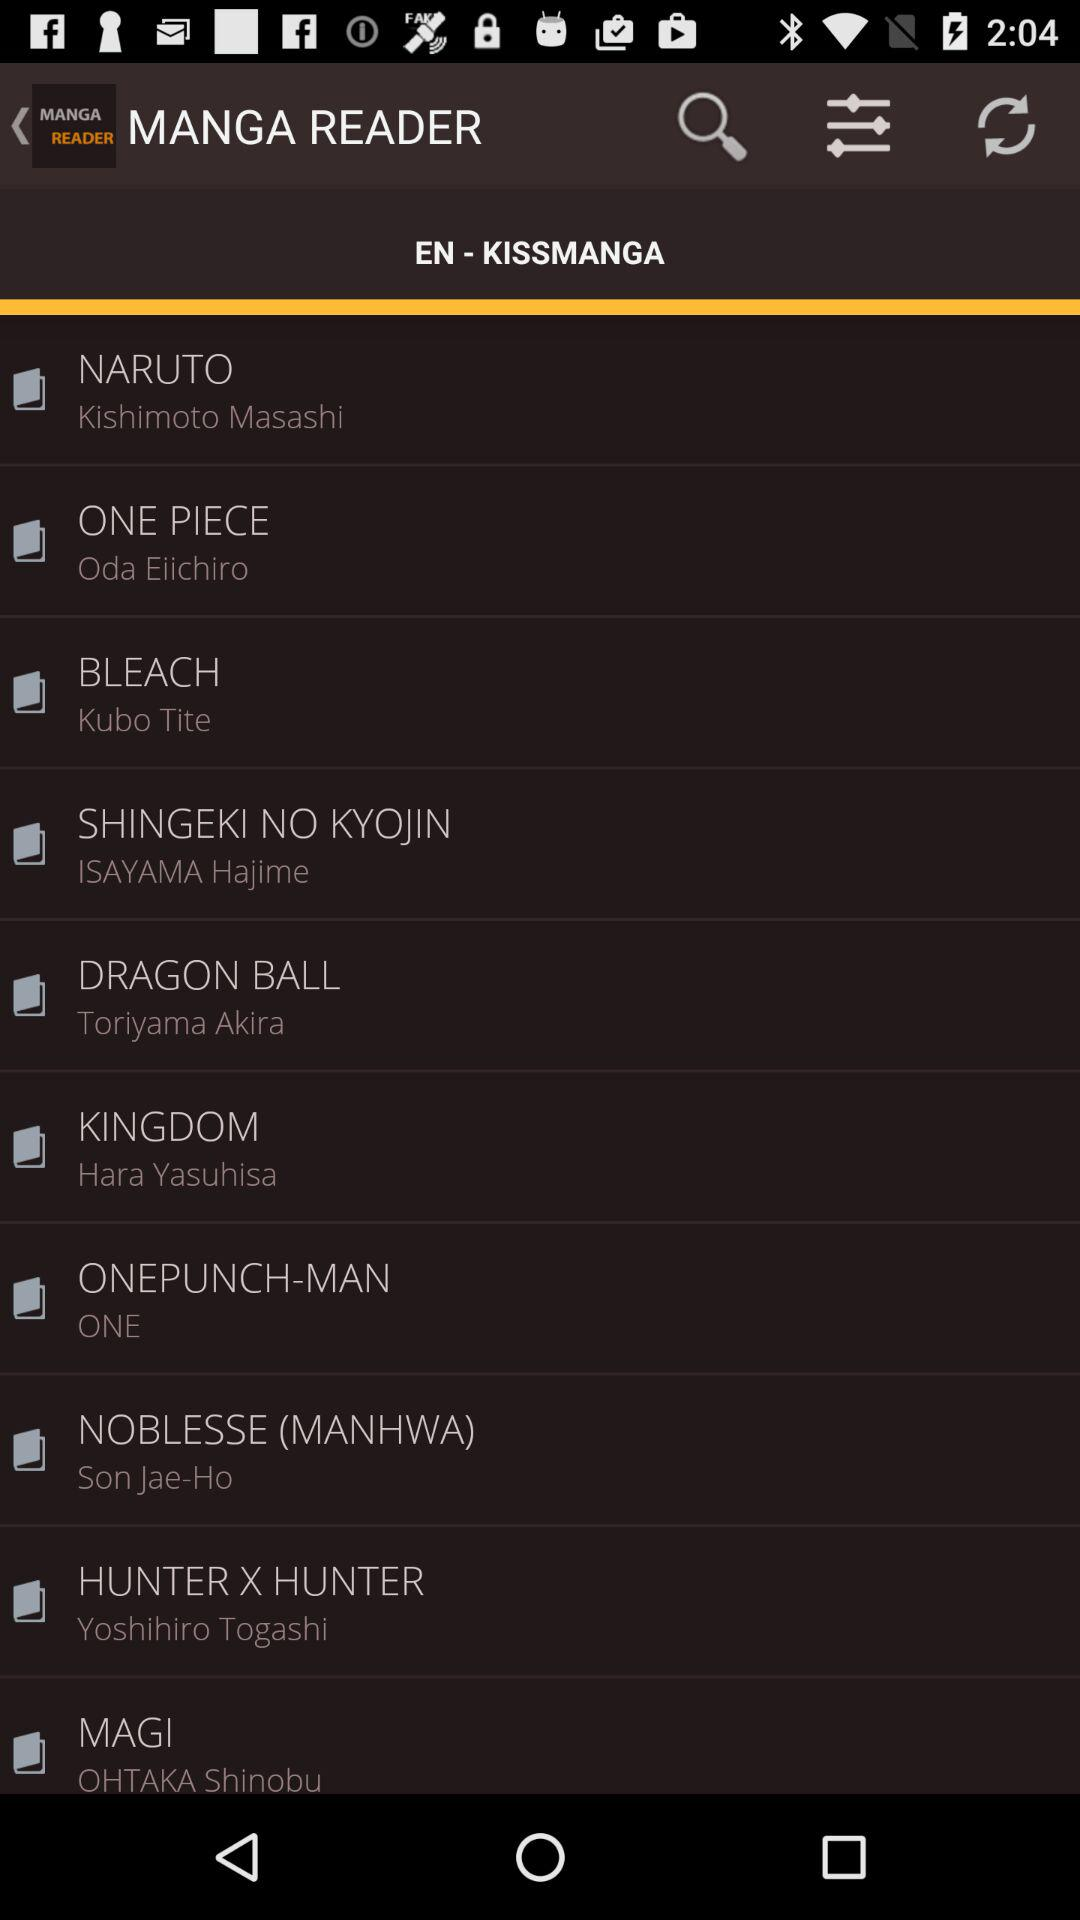What is the name of the application? The application name is "MANGA READER". 